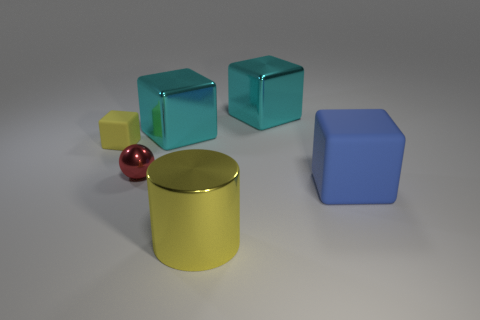Subtract 1 blocks. How many blocks are left? 3 Add 2 blue things. How many objects exist? 8 Subtract all blocks. How many objects are left? 2 Add 4 tiny cubes. How many tiny cubes are left? 5 Add 1 metallic cylinders. How many metallic cylinders exist? 2 Subtract 0 brown balls. How many objects are left? 6 Subtract all cyan rubber cylinders. Subtract all large cyan things. How many objects are left? 4 